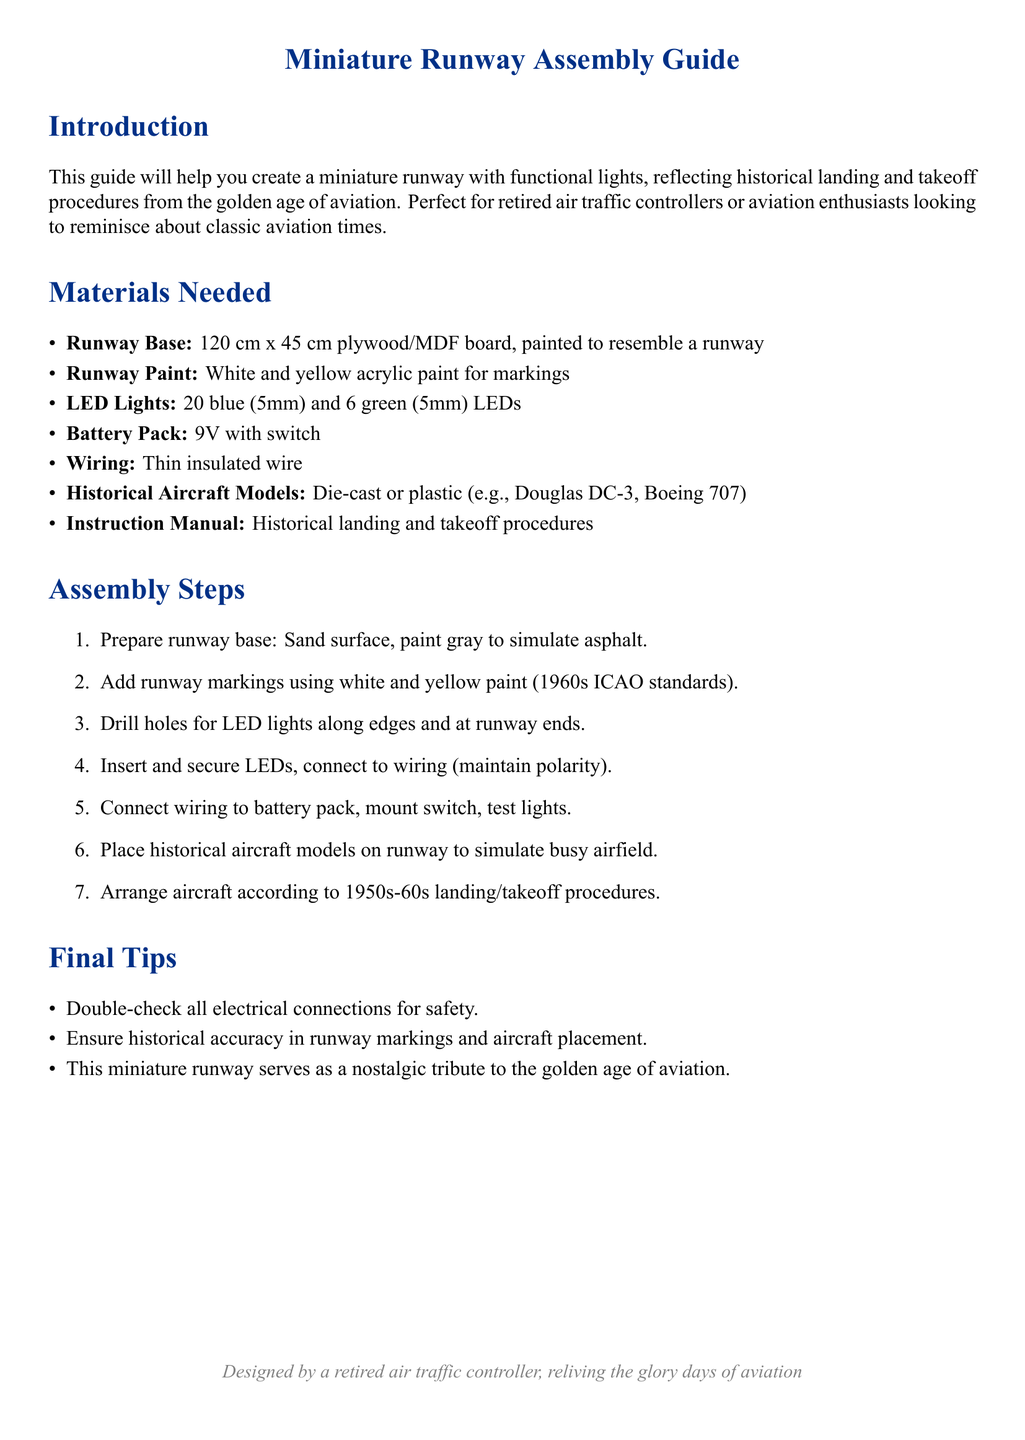What is the size of the runway base? The runway base size is specified in the document as 120 cm x 45 cm.
Answer: 120 cm x 45 cm How many blue LEDs are needed? The document lists the number of each type of LED required for the assembly, stating 20 blue LEDs.
Answer: 20 What color is the runway paint described in the materials needed? The document mentions two colors for runway paint: white and yellow.
Answer: White and yellow Which historical aircraft models are suggested? The document provides examples of historical aircraft models to use, naming the Douglas DC-3 and Boeing 707.
Answer: Douglas DC-3, Boeing 707 What should be done with LED lights during connection? The instruction details that the wiring needs to maintain polarity when connecting the lights.
Answer: Maintain polarity What is the purpose of the miniature runway according to the introduction? The introduction highlights that the runway serves as a nostalgic tribute to a specific era of aviation.
Answer: Nostalgic tribute How are runway markings supposed to be painted? The document specifies that the runway markings should follow the 1960s ICAO standards.
Answer: 1960s ICAO standards What battery needs to be used for the lights? A specific item required for powering the lights is indicated as a 9V battery pack.
Answer: 9V battery pack What is advised to double-check for safety? The final tips section provides a reminder about safety pertaining to electrical connections.
Answer: Electrical connections 